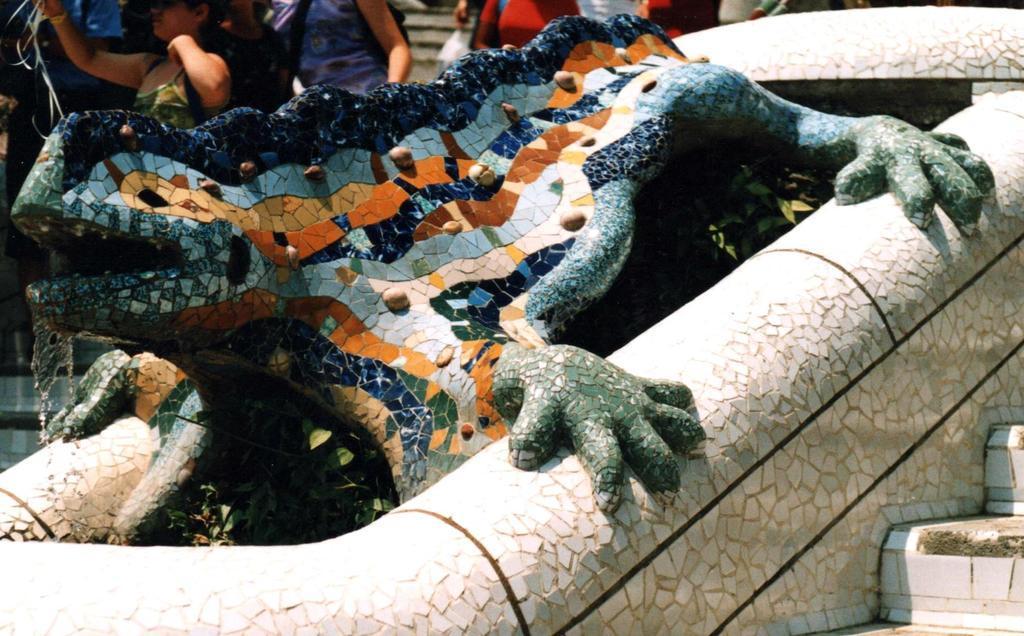Describe this image in one or two sentences. In this picture there is a stone and ceramic lizard statue placed in the front bottom side. Behind there is a group of girls standing and taking the photographs. 